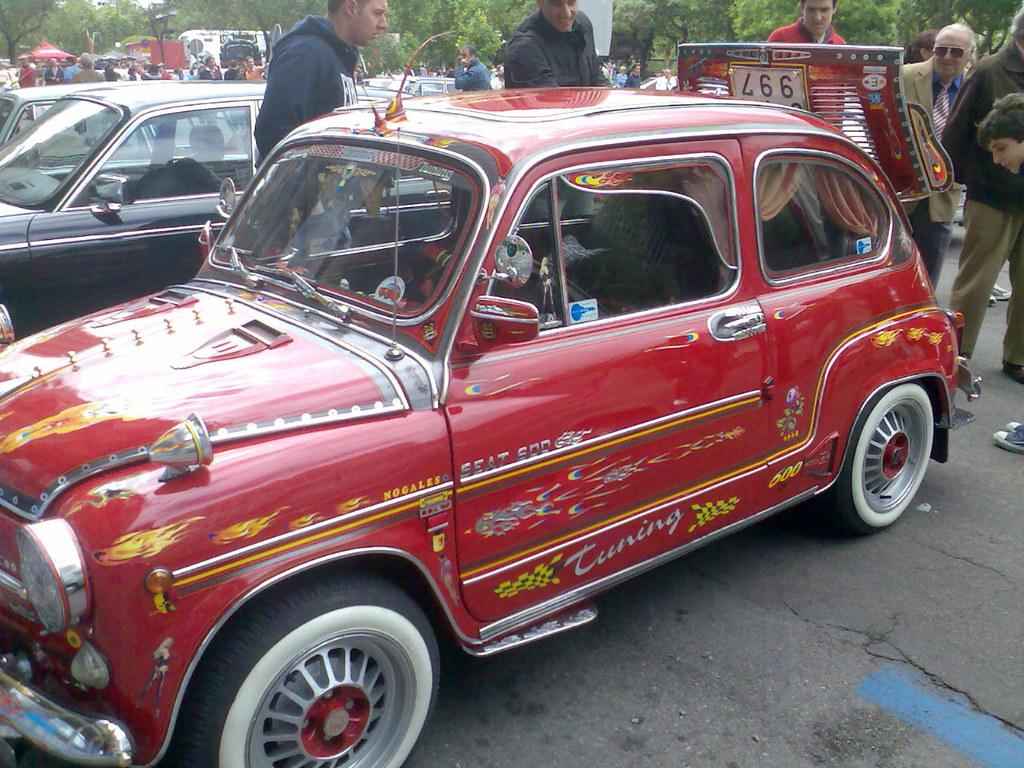<image>
Create a compact narrative representing the image presented. a red antique car with the word Tuning on the body 